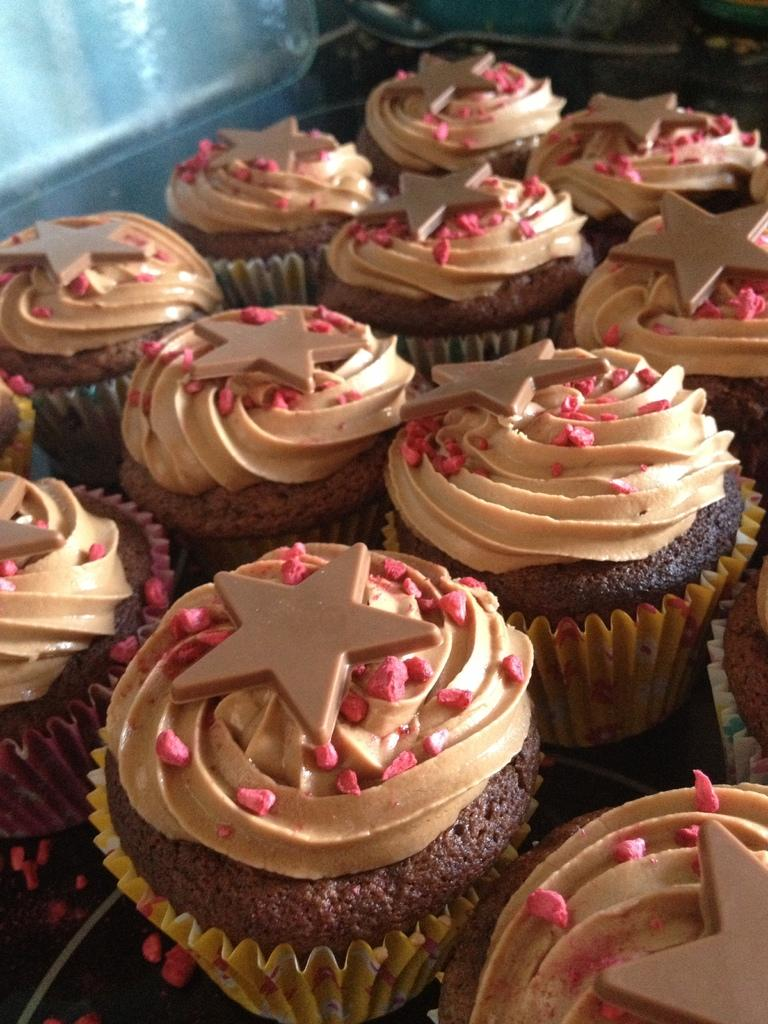What type of food can be seen on the surface in the image? There are cupcakes on a surface in the image. Can you describe any utensils or tools visible in the image? There is a spoon in the background of the image. What else can be seen in the background of the image? There are some unspecified objects in the background of the image. What type of cloud can be seen in the image? There is no cloud present in the image; it is a close-up shot of cupcakes and other objects. 